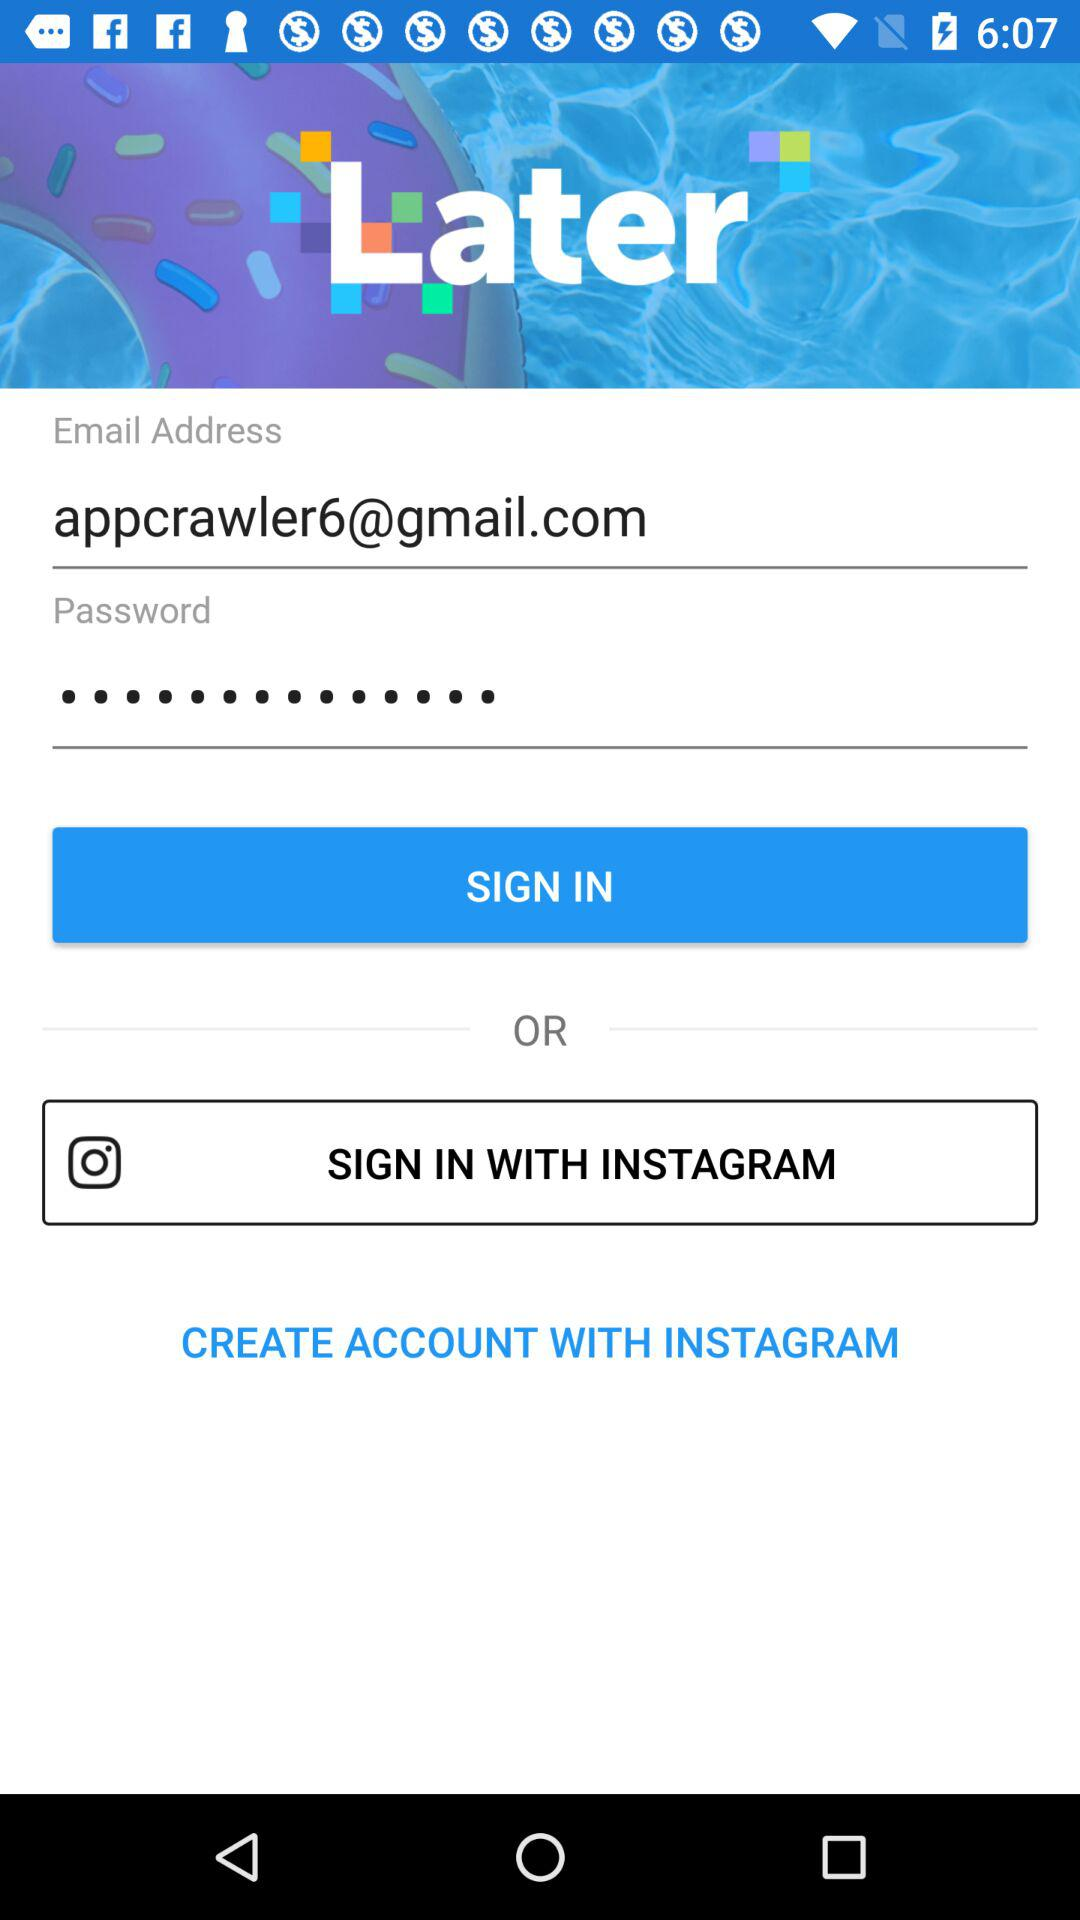What is the email address? The email address is appcrawler6@gmail.com. 